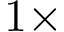Convert formula to latex. <formula><loc_0><loc_0><loc_500><loc_500>1 \times</formula> 